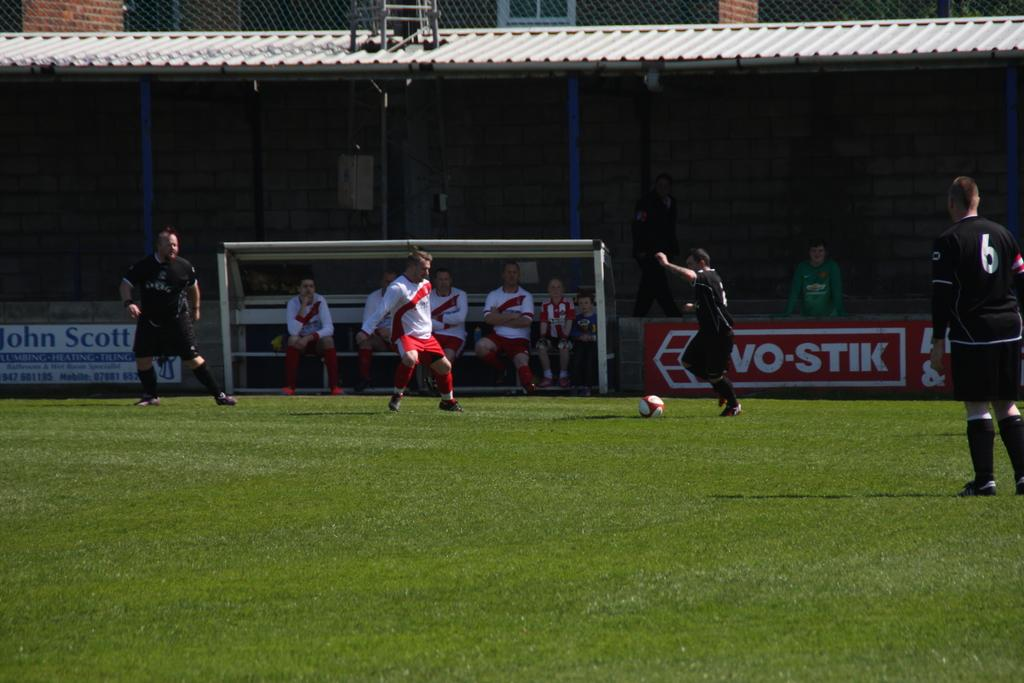<image>
Offer a succinct explanation of the picture presented. Soccer players on a field, with one of the black jerseys has the number 6. 